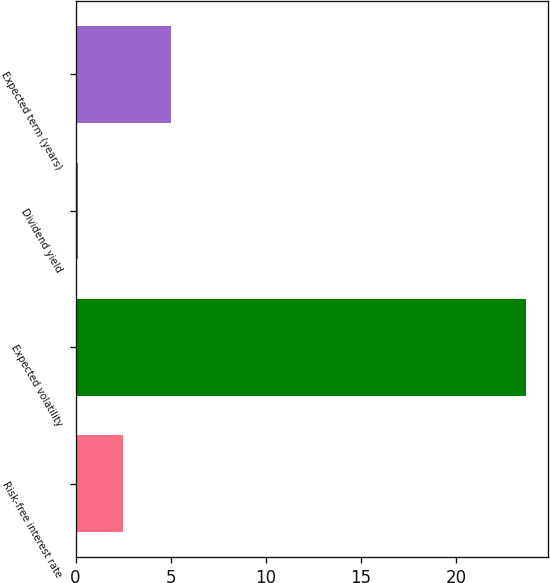Convert chart. <chart><loc_0><loc_0><loc_500><loc_500><bar_chart><fcel>Risk-free interest rate<fcel>Expected volatility<fcel>Dividend yield<fcel>Expected term (years)<nl><fcel>2.48<fcel>23.65<fcel>0.13<fcel>5<nl></chart> 